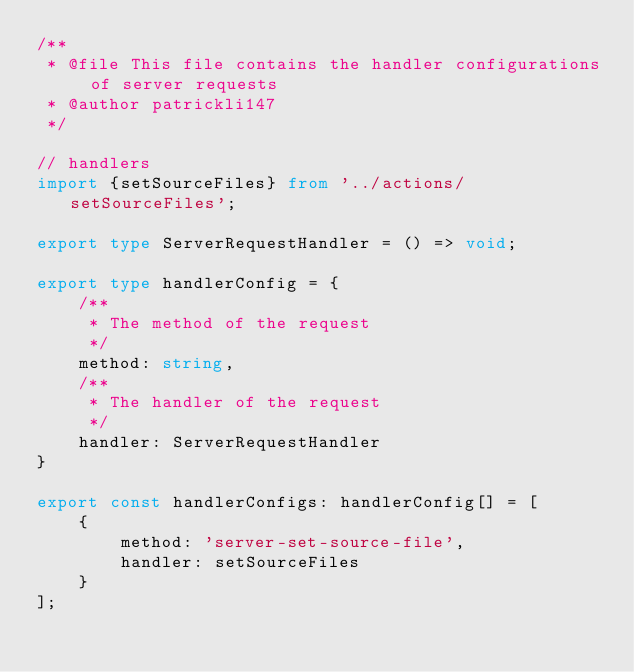<code> <loc_0><loc_0><loc_500><loc_500><_TypeScript_>/**
 * @file This file contains the handler configurations of server requests
 * @author patrickli147
 */

// handlers
import {setSourceFiles} from '../actions/setSourceFiles';

export type ServerRequestHandler = () => void;

export type handlerConfig = {
	/**
	 * The method of the request
	 */
	method: string,
	/**
	 * The handler of the request
	 */
	handler: ServerRequestHandler
}

export const handlerConfigs: handlerConfig[] = [
	{
		method: 'server-set-source-file',
		handler: setSourceFiles
	}
];

</code> 